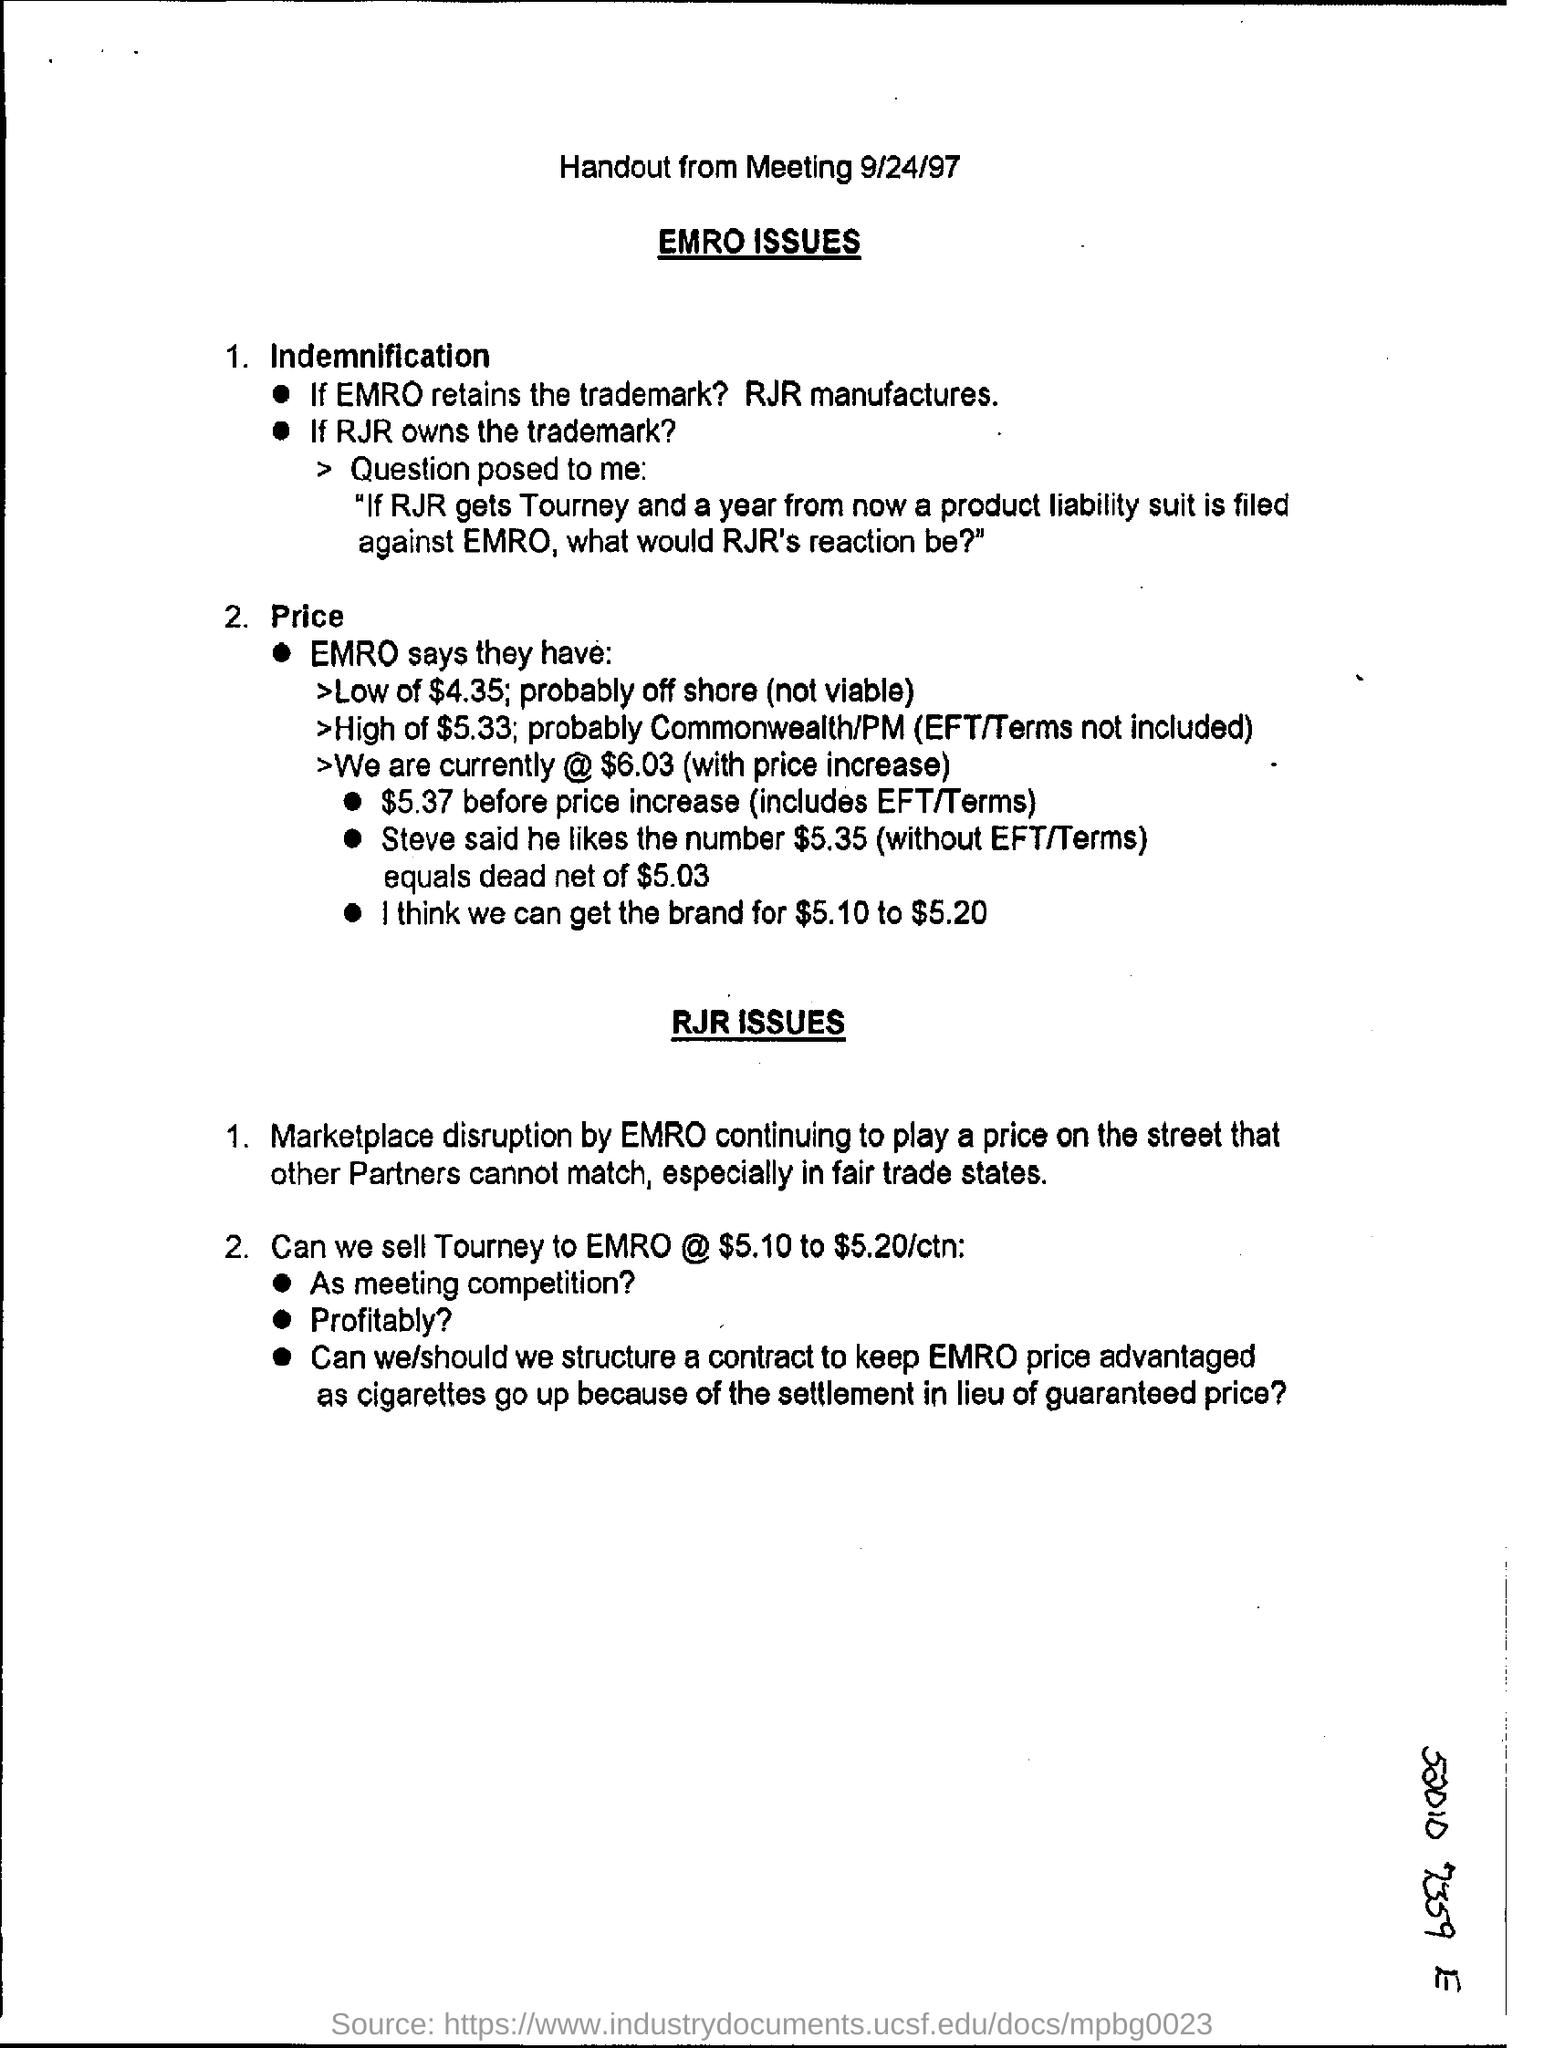What is the date at top of the page ?
Offer a very short reply. 9/24/97. 